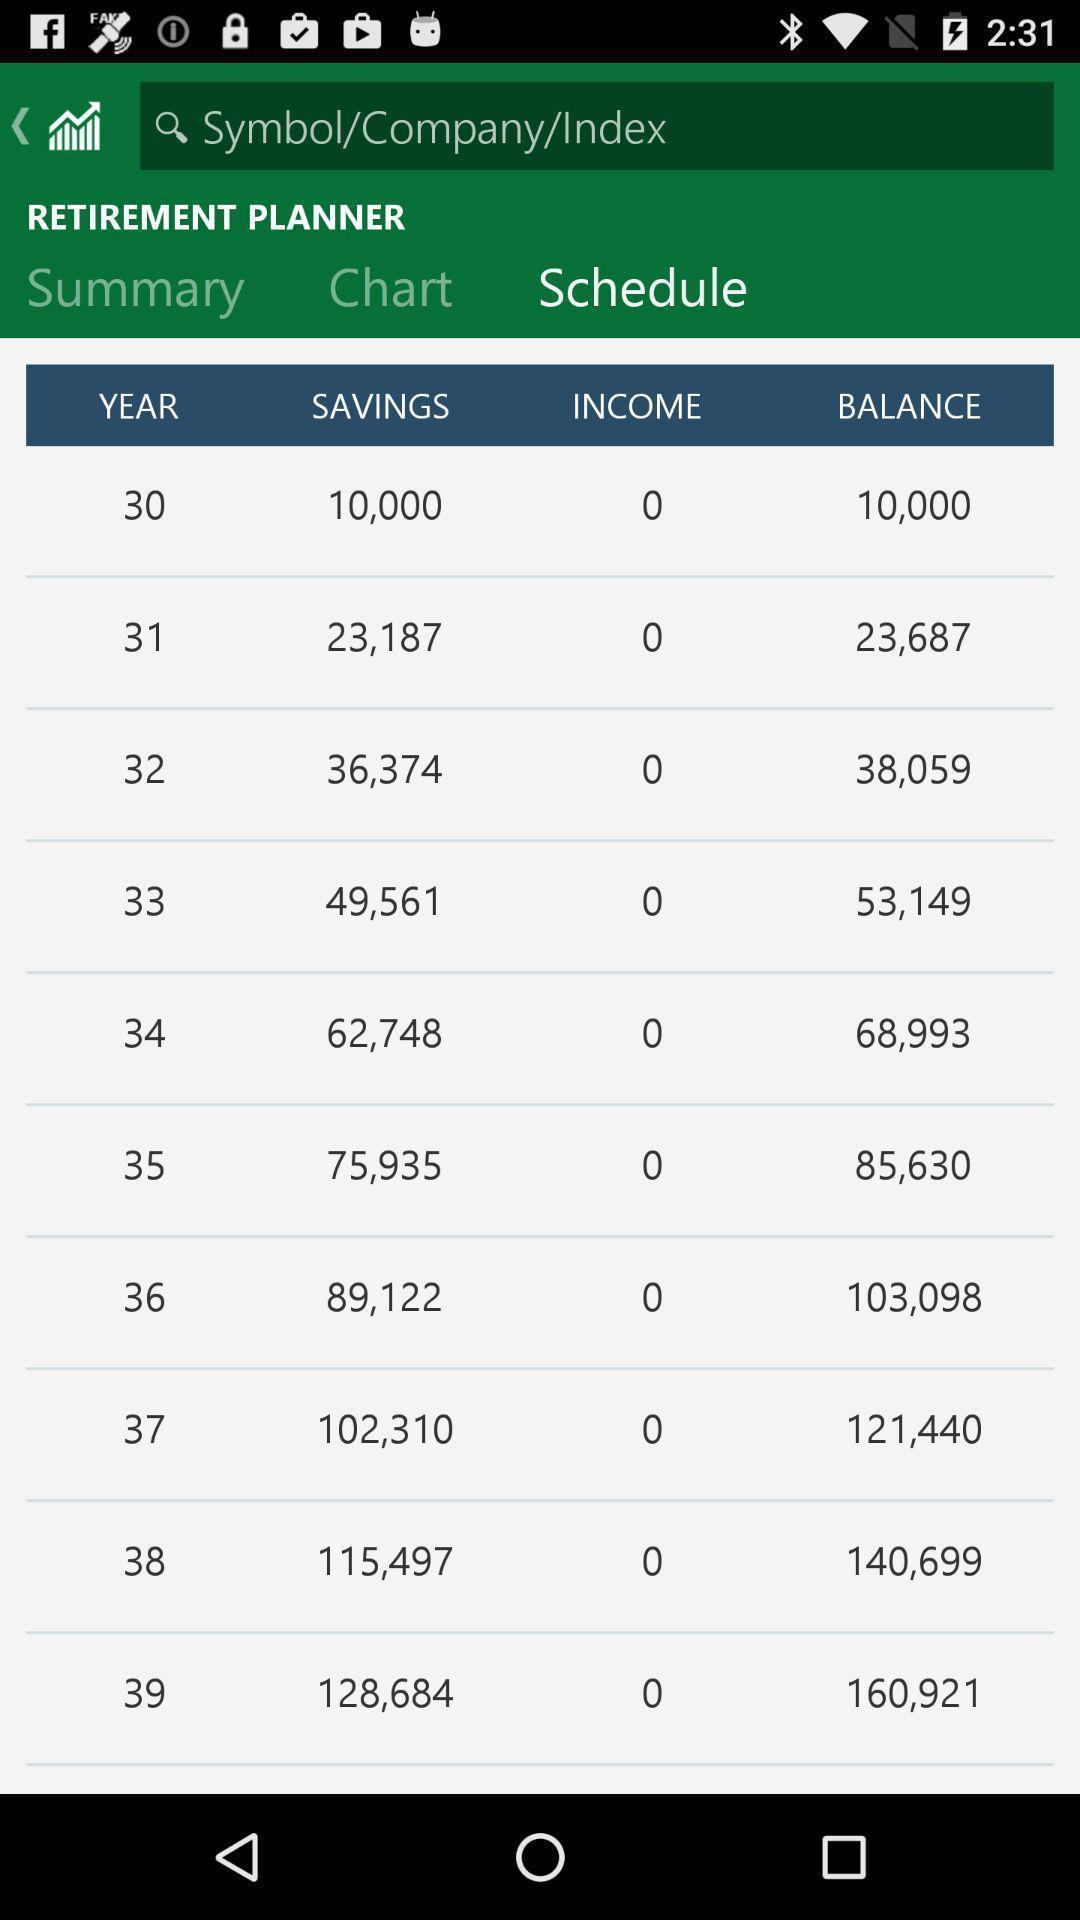Summarize the main components in this picture. Page that displaying financial data. 